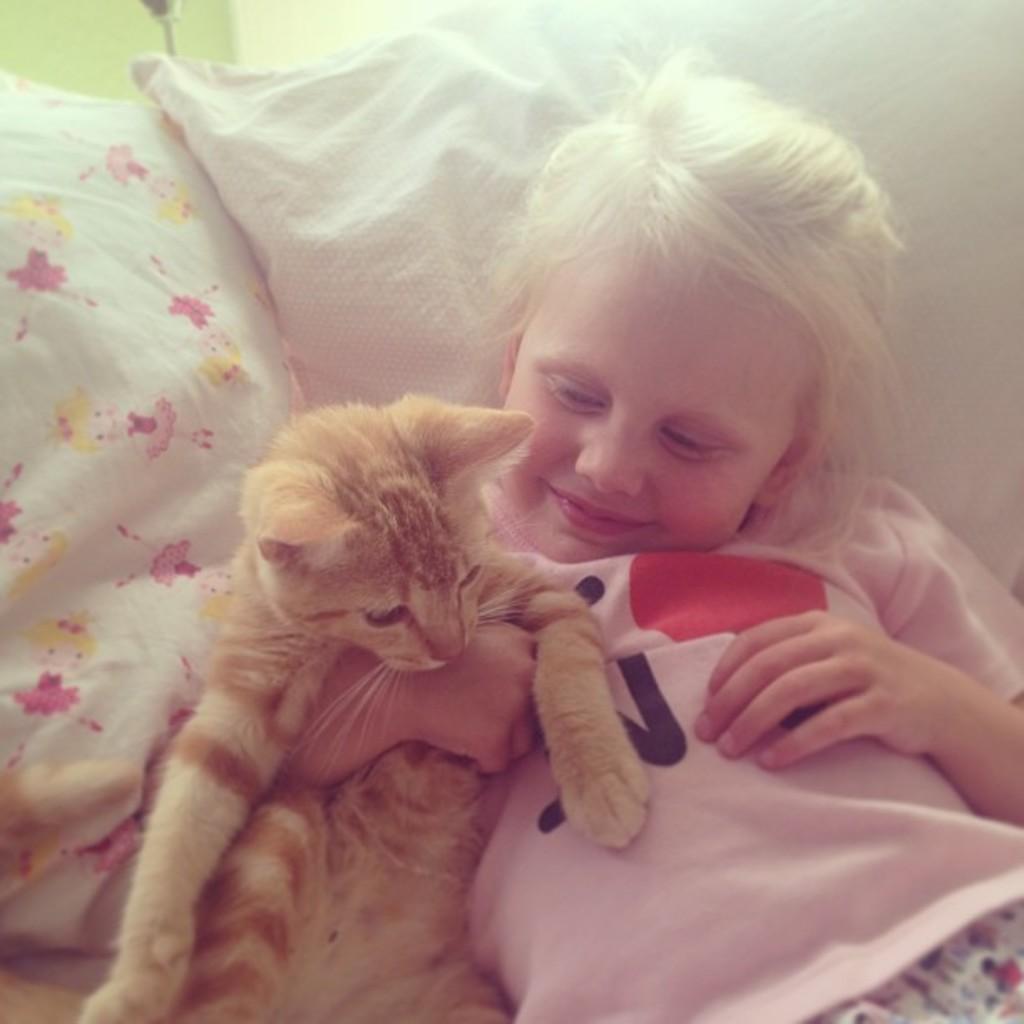Please provide a concise description of this image. This is the picture of a girl who is holding a cat and leaning on the pillow. 